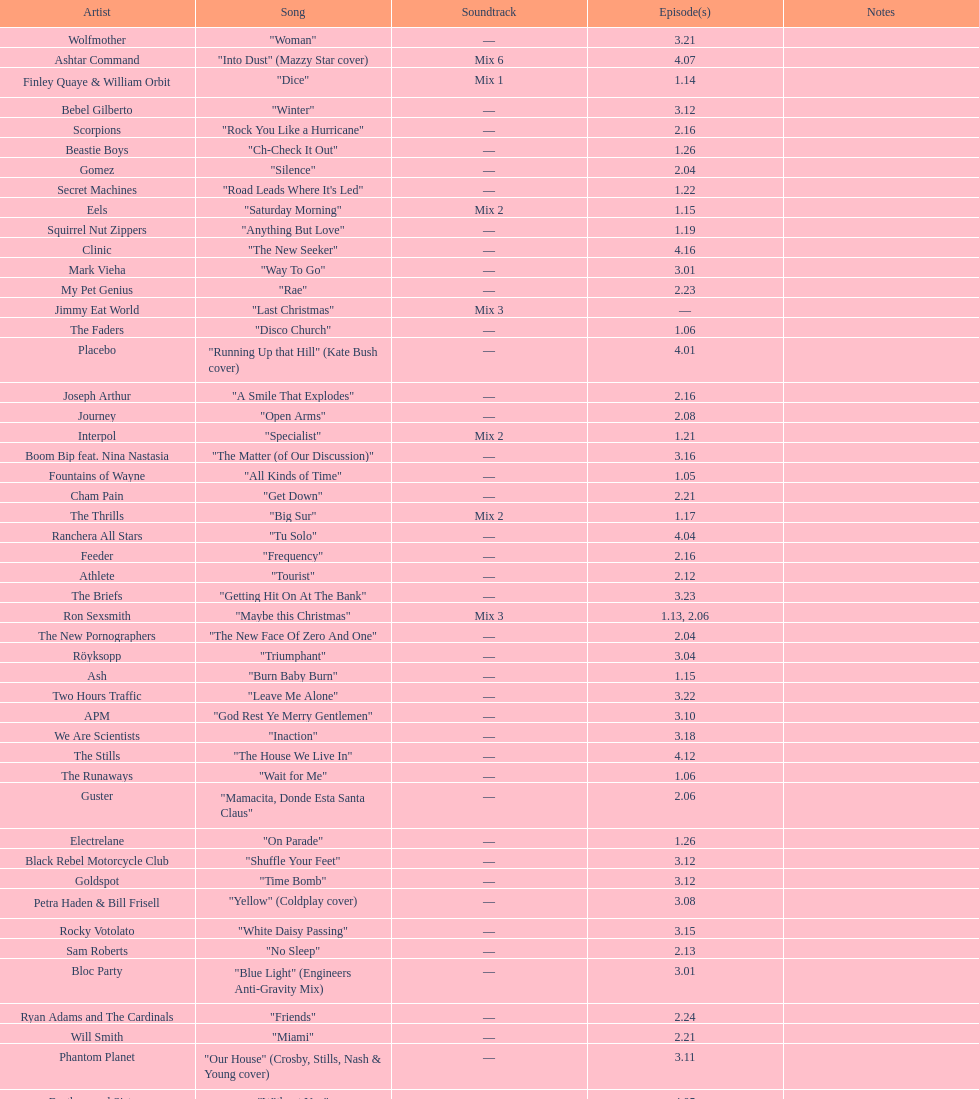How many consecutive songs were by the album leaf? 6. 